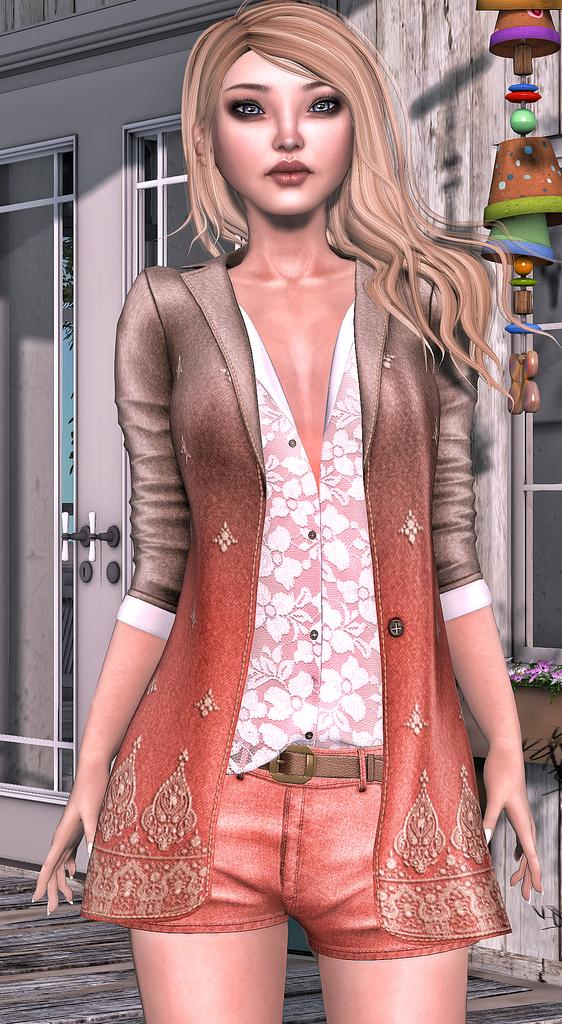What type of art is depicted in the image? The image is digital art. Who or what is the main subject of the art? The subject of the art is a girl. What can be seen in the background of the art? There are doors in the background of the art. What is present at the top of the art? There is hanging at the top of the art. What rhythm is the girl following in the digital art? The image does not depict any rhythm or movement, as it is a still digital art piece. 